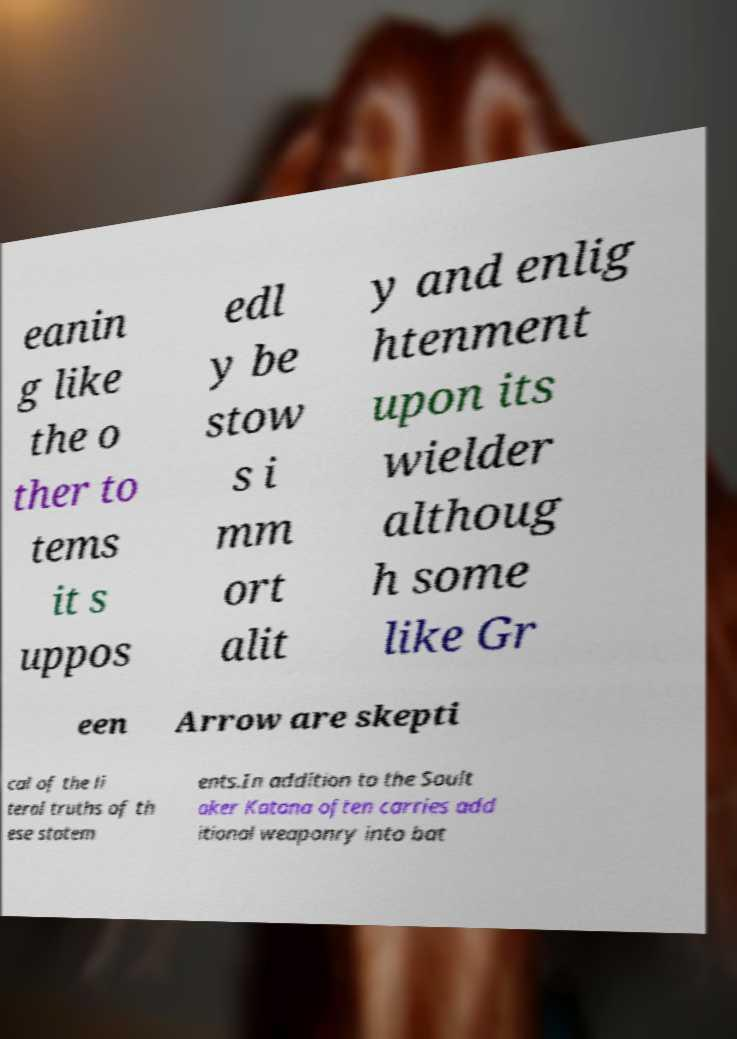Could you extract and type out the text from this image? eanin g like the o ther to tems it s uppos edl y be stow s i mm ort alit y and enlig htenment upon its wielder althoug h some like Gr een Arrow are skepti cal of the li teral truths of th ese statem ents.In addition to the Soult aker Katana often carries add itional weaponry into bat 